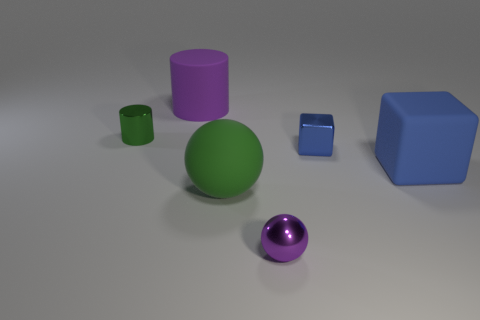Add 3 purple cubes. How many objects exist? 9 Subtract all cubes. How many objects are left? 4 Add 2 large purple metal cylinders. How many large purple metal cylinders exist? 2 Subtract 0 yellow cylinders. How many objects are left? 6 Subtract all blue rubber objects. Subtract all purple matte cylinders. How many objects are left? 4 Add 6 rubber objects. How many rubber objects are left? 9 